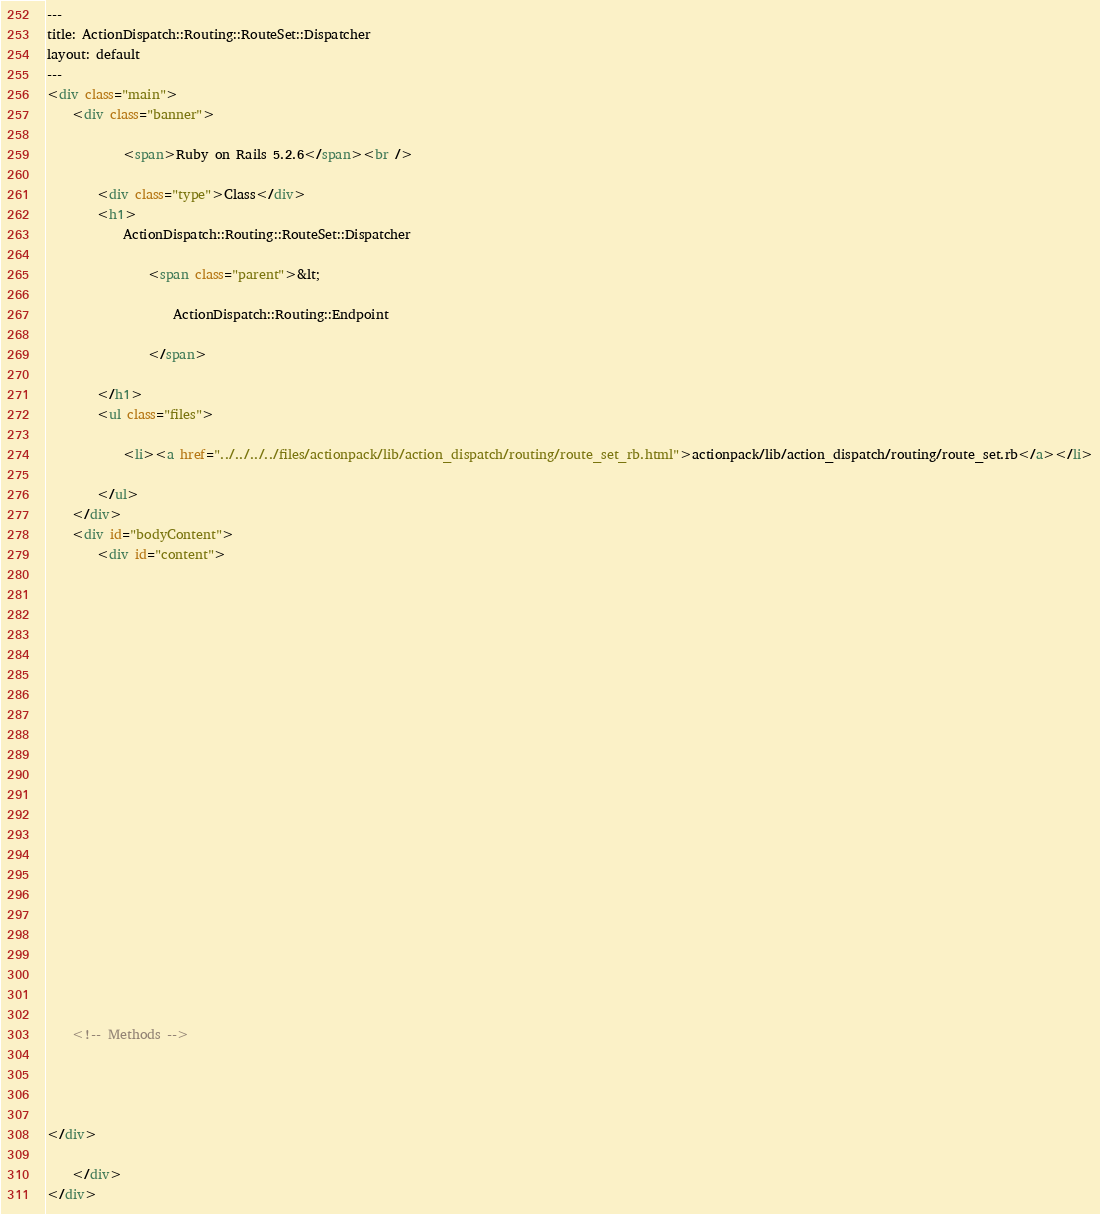<code> <loc_0><loc_0><loc_500><loc_500><_HTML_>---
title: ActionDispatch::Routing::RouteSet::Dispatcher
layout: default
---
<div class="main">
    <div class="banner">
        
            <span>Ruby on Rails 5.2.6</span><br />
        
        <div class="type">Class</div>
        <h1>
            ActionDispatch::Routing::RouteSet::Dispatcher
            
                <span class="parent">&lt;
                    
                    ActionDispatch::Routing::Endpoint
                    
                </span>
            
        </h1>
        <ul class="files">
            
            <li><a href="../../../../files/actionpack/lib/action_dispatch/routing/route_set_rb.html">actionpack/lib/action_dispatch/routing/route_set.rb</a></li>
            
        </ul>
    </div>
    <div id="bodyContent">
        <div id="content">
  

  

  
  


  

  

  

  
    

    

    

    

    <!-- Methods -->
    
    
    
  
</div>

    </div>
</div>
</code> 